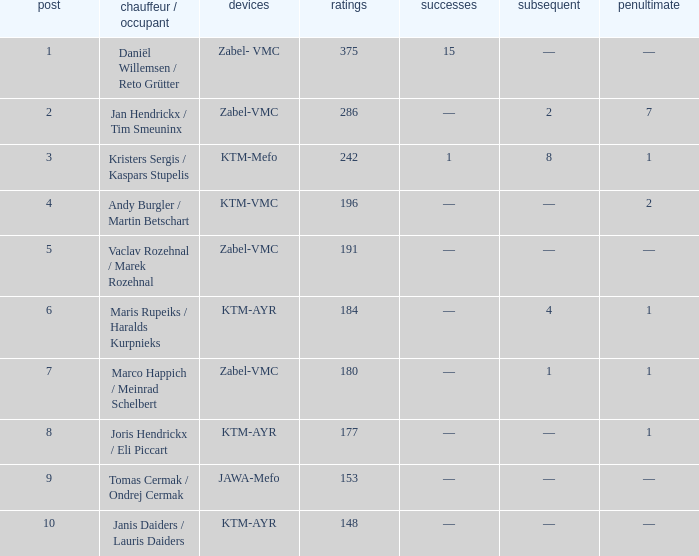What was the highest points when the second was 4? 184.0. 